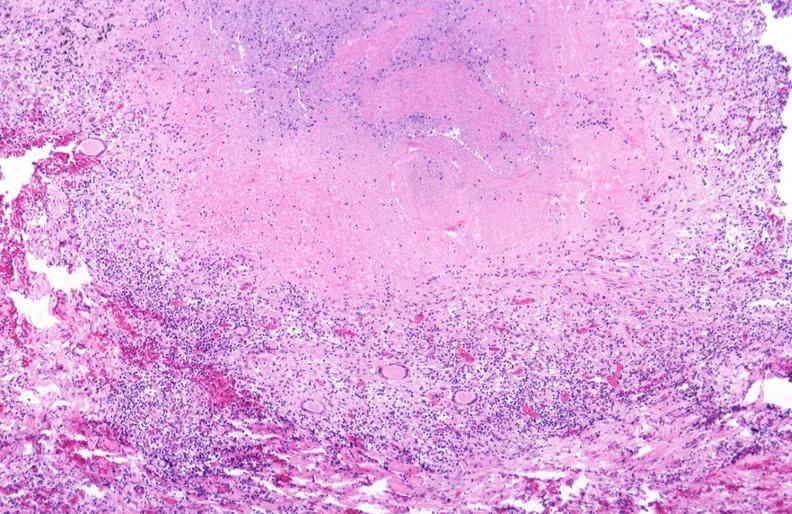what does this image show?
Answer the question using a single word or phrase. Lung 